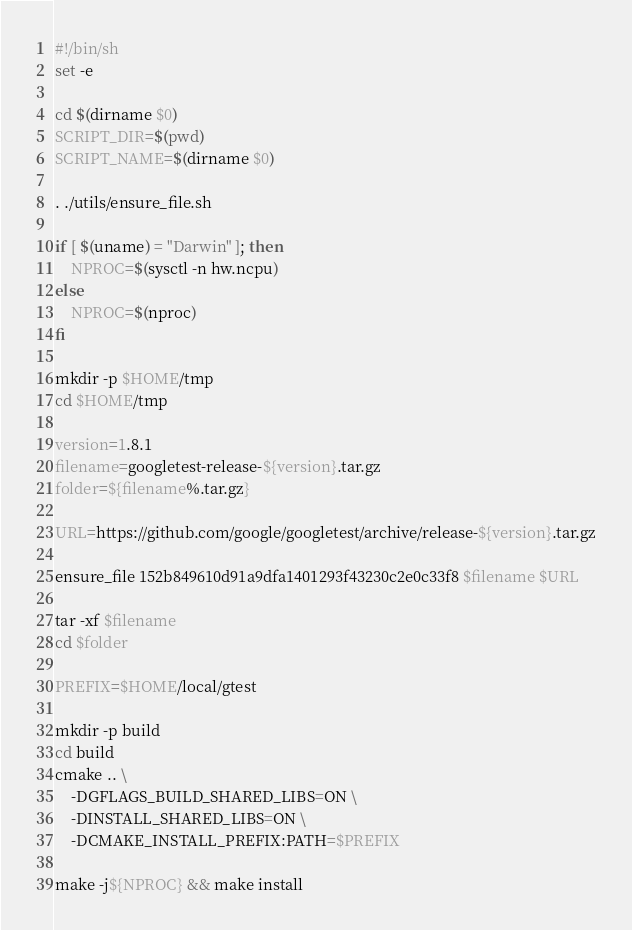<code> <loc_0><loc_0><loc_500><loc_500><_Bash_>#!/bin/sh
set -e

cd $(dirname $0)
SCRIPT_DIR=$(pwd)
SCRIPT_NAME=$(dirname $0)

. ./utils/ensure_file.sh

if [ $(uname) = "Darwin" ]; then
    NPROC=$(sysctl -n hw.ncpu)
else
    NPROC=$(nproc)
fi

mkdir -p $HOME/tmp
cd $HOME/tmp

version=1.8.1
filename=googletest-release-${version}.tar.gz
folder=${filename%.tar.gz}

URL=https://github.com/google/googletest/archive/release-${version}.tar.gz

ensure_file 152b849610d91a9dfa1401293f43230c2e0c33f8 $filename $URL

tar -xf $filename
cd $folder

PREFIX=$HOME/local/gtest

mkdir -p build
cd build
cmake .. \
    -DGFLAGS_BUILD_SHARED_LIBS=ON \
    -DINSTALL_SHARED_LIBS=ON \
    -DCMAKE_INSTALL_PREFIX:PATH=$PREFIX

make -j${NPROC} && make install
</code> 